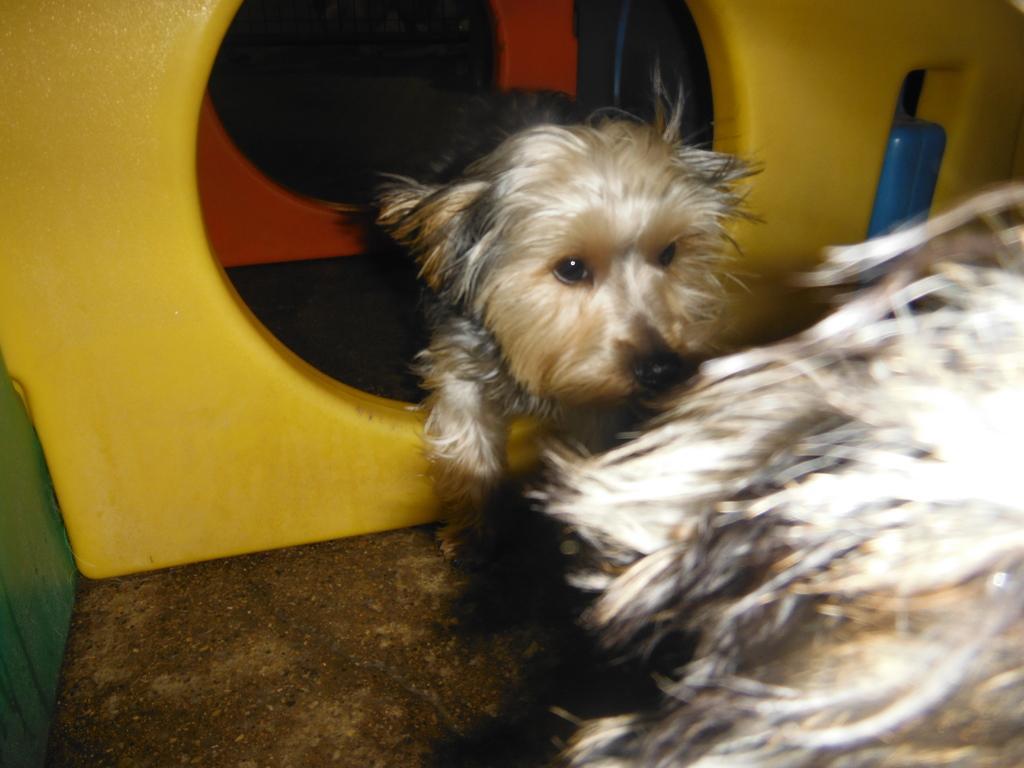In one or two sentences, can you explain what this image depicts? In this picture I can see a dog and looks like a dog house. 